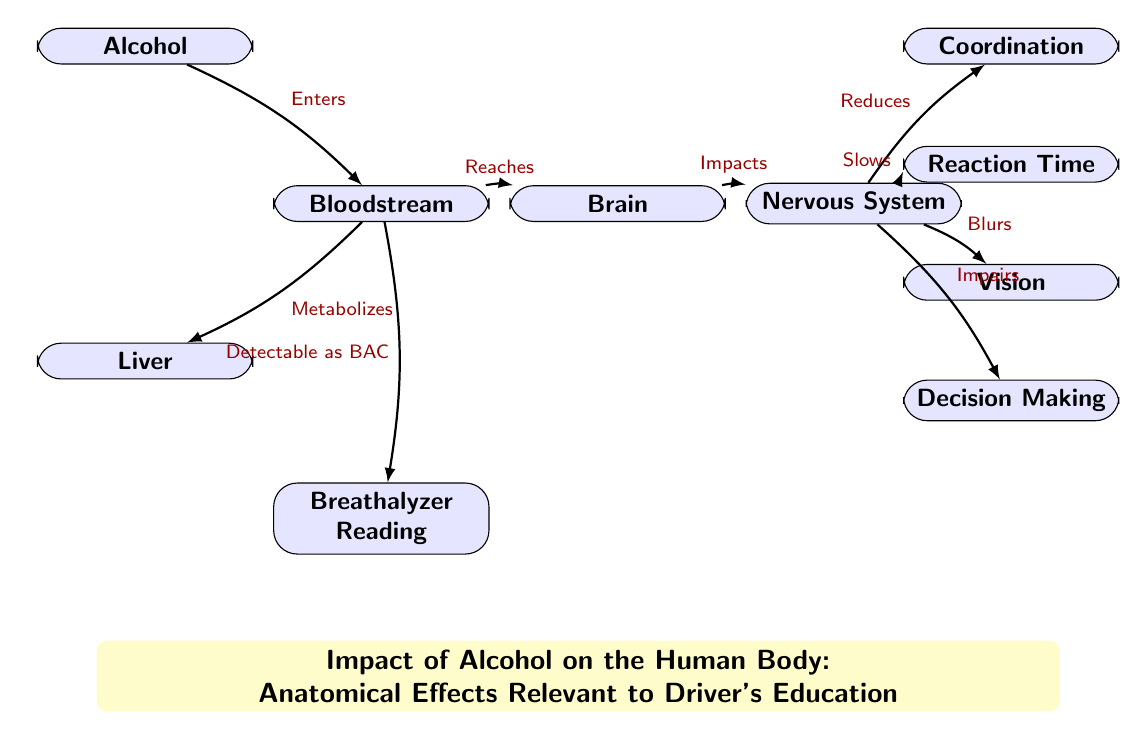What is the first node in the diagram? The diagram starts with the node labeled "Alcohol," indicating this is where the process begins.
Answer: Alcohol How many nodes are present in the diagram? There are a total of 9 nodes in the diagram that represent different components affected by alcohol.
Answer: 9 What does "Bloodstream" directly impact? The "Bloodstream" node leads to two direct paths: one to the "Liver" for metabolization, and one to the "Brain," indicating impacts on both areas.
Answer: Brain, Liver What effect does alcohol have on "Coordination"? The diagram indicates that alcohol "Reduces" coordination through its effects on the nervous system.
Answer: Reduces What is the relationship between "Brain" and "Nervous System"? The "Brain" directly impacts the "Nervous System," showing how alcohol's effects on the brain influence nervous functions.
Answer: Impacts What is detected as "BAC"? The "Bloodstream" is the source from which alcohol is detectable as Blood Alcohol Concentration (BAC), indicating the level of alcohol in the body.
Answer: Breathalyzer What is the last effect mentioned in the diagram? The last effect described relates to "Decision Making," highlighting a critical impairment that could influence driving behaviors under alcohol's influence.
Answer: Decision Making How does alcohol affect "Reaction Time"? The diagram shows that alcohol "Slows" reaction time through its impact on the nervous system, which is crucial for safe driving.
Answer: Slows What are the two main effects of alcohol mentioned that impact vision? The diagram indicates that alcohol "Blurs" vision, which is another significant impairment relevant to driving.
Answer: Blurs What node connects to the "Breathalyzer Reading"? The "Bloodstream" node connects to the "Breathalyzer Reading," illustrating how alcohol's presence in the bloodstream is measured.
Answer: Bloodstream 